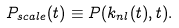<formula> <loc_0><loc_0><loc_500><loc_500>P _ { s c a l e } ( t ) \equiv P ( k _ { n l } ( t ) , t ) .</formula> 